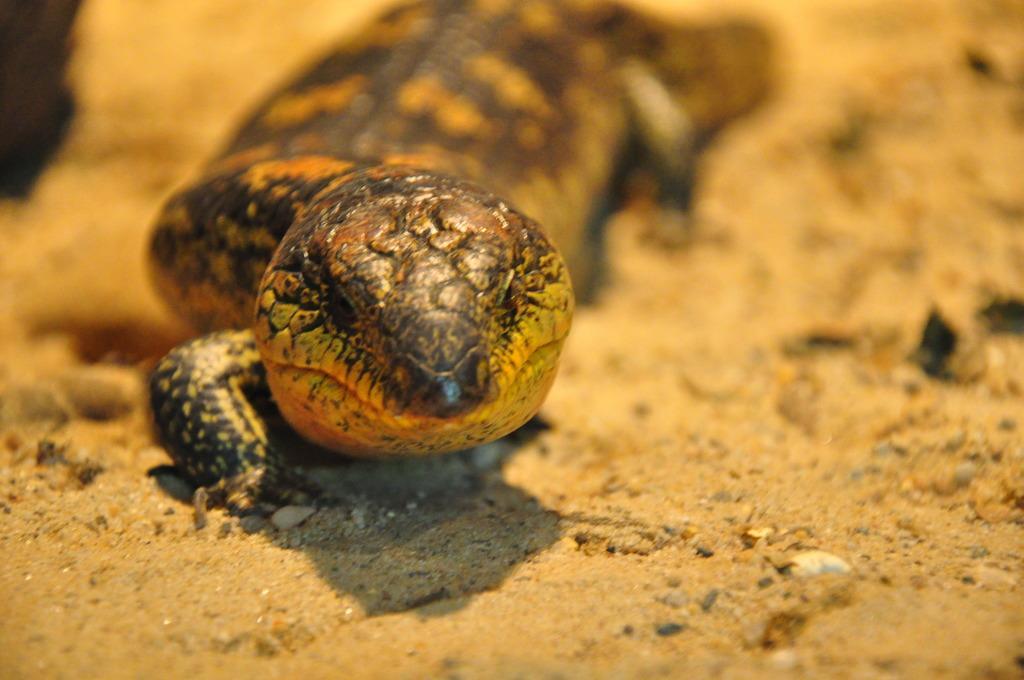In one or two sentences, can you explain what this image depicts? In this image there is a salamander on the ground. 